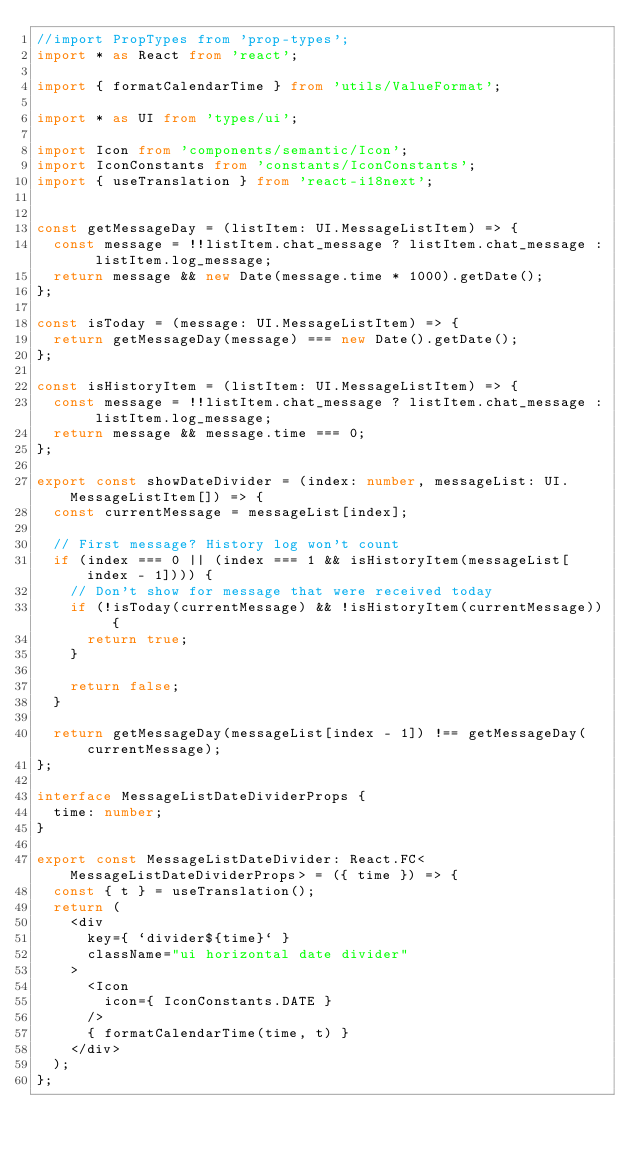Convert code to text. <code><loc_0><loc_0><loc_500><loc_500><_TypeScript_>//import PropTypes from 'prop-types';
import * as React from 'react';

import { formatCalendarTime } from 'utils/ValueFormat';

import * as UI from 'types/ui';

import Icon from 'components/semantic/Icon';
import IconConstants from 'constants/IconConstants';
import { useTranslation } from 'react-i18next';


const getMessageDay = (listItem: UI.MessageListItem) => {
  const message = !!listItem.chat_message ? listItem.chat_message : listItem.log_message;
  return message && new Date(message.time * 1000).getDate();
};

const isToday = (message: UI.MessageListItem) => {
  return getMessageDay(message) === new Date().getDate();
};

const isHistoryItem = (listItem: UI.MessageListItem) => {
  const message = !!listItem.chat_message ? listItem.chat_message : listItem.log_message;
  return message && message.time === 0; 
};

export const showDateDivider = (index: number, messageList: UI.MessageListItem[]) => {
  const currentMessage = messageList[index];

  // First message? History log won't count
  if (index === 0 || (index === 1 && isHistoryItem(messageList[index - 1]))) {
    // Don't show for message that were received today
    if (!isToday(currentMessage) && !isHistoryItem(currentMessage)) {
      return true;
    }

    return false;
  }

  return getMessageDay(messageList[index - 1]) !== getMessageDay(currentMessage);
};

interface MessageListDateDividerProps {
  time: number;
}

export const MessageListDateDivider: React.FC<MessageListDateDividerProps> = ({ time }) => {
  const { t } = useTranslation();
  return (
    <div 
      key={ `divider${time}` }
      className="ui horizontal date divider"
    >
      <Icon 
        icon={ IconConstants.DATE }
      />
      { formatCalendarTime(time, t) }
    </div>
  );
};
</code> 